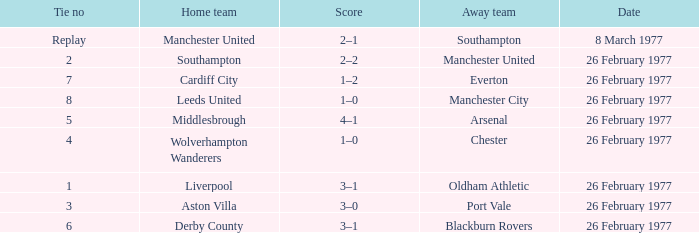Who was the home team that played against Manchester United? Southampton. 